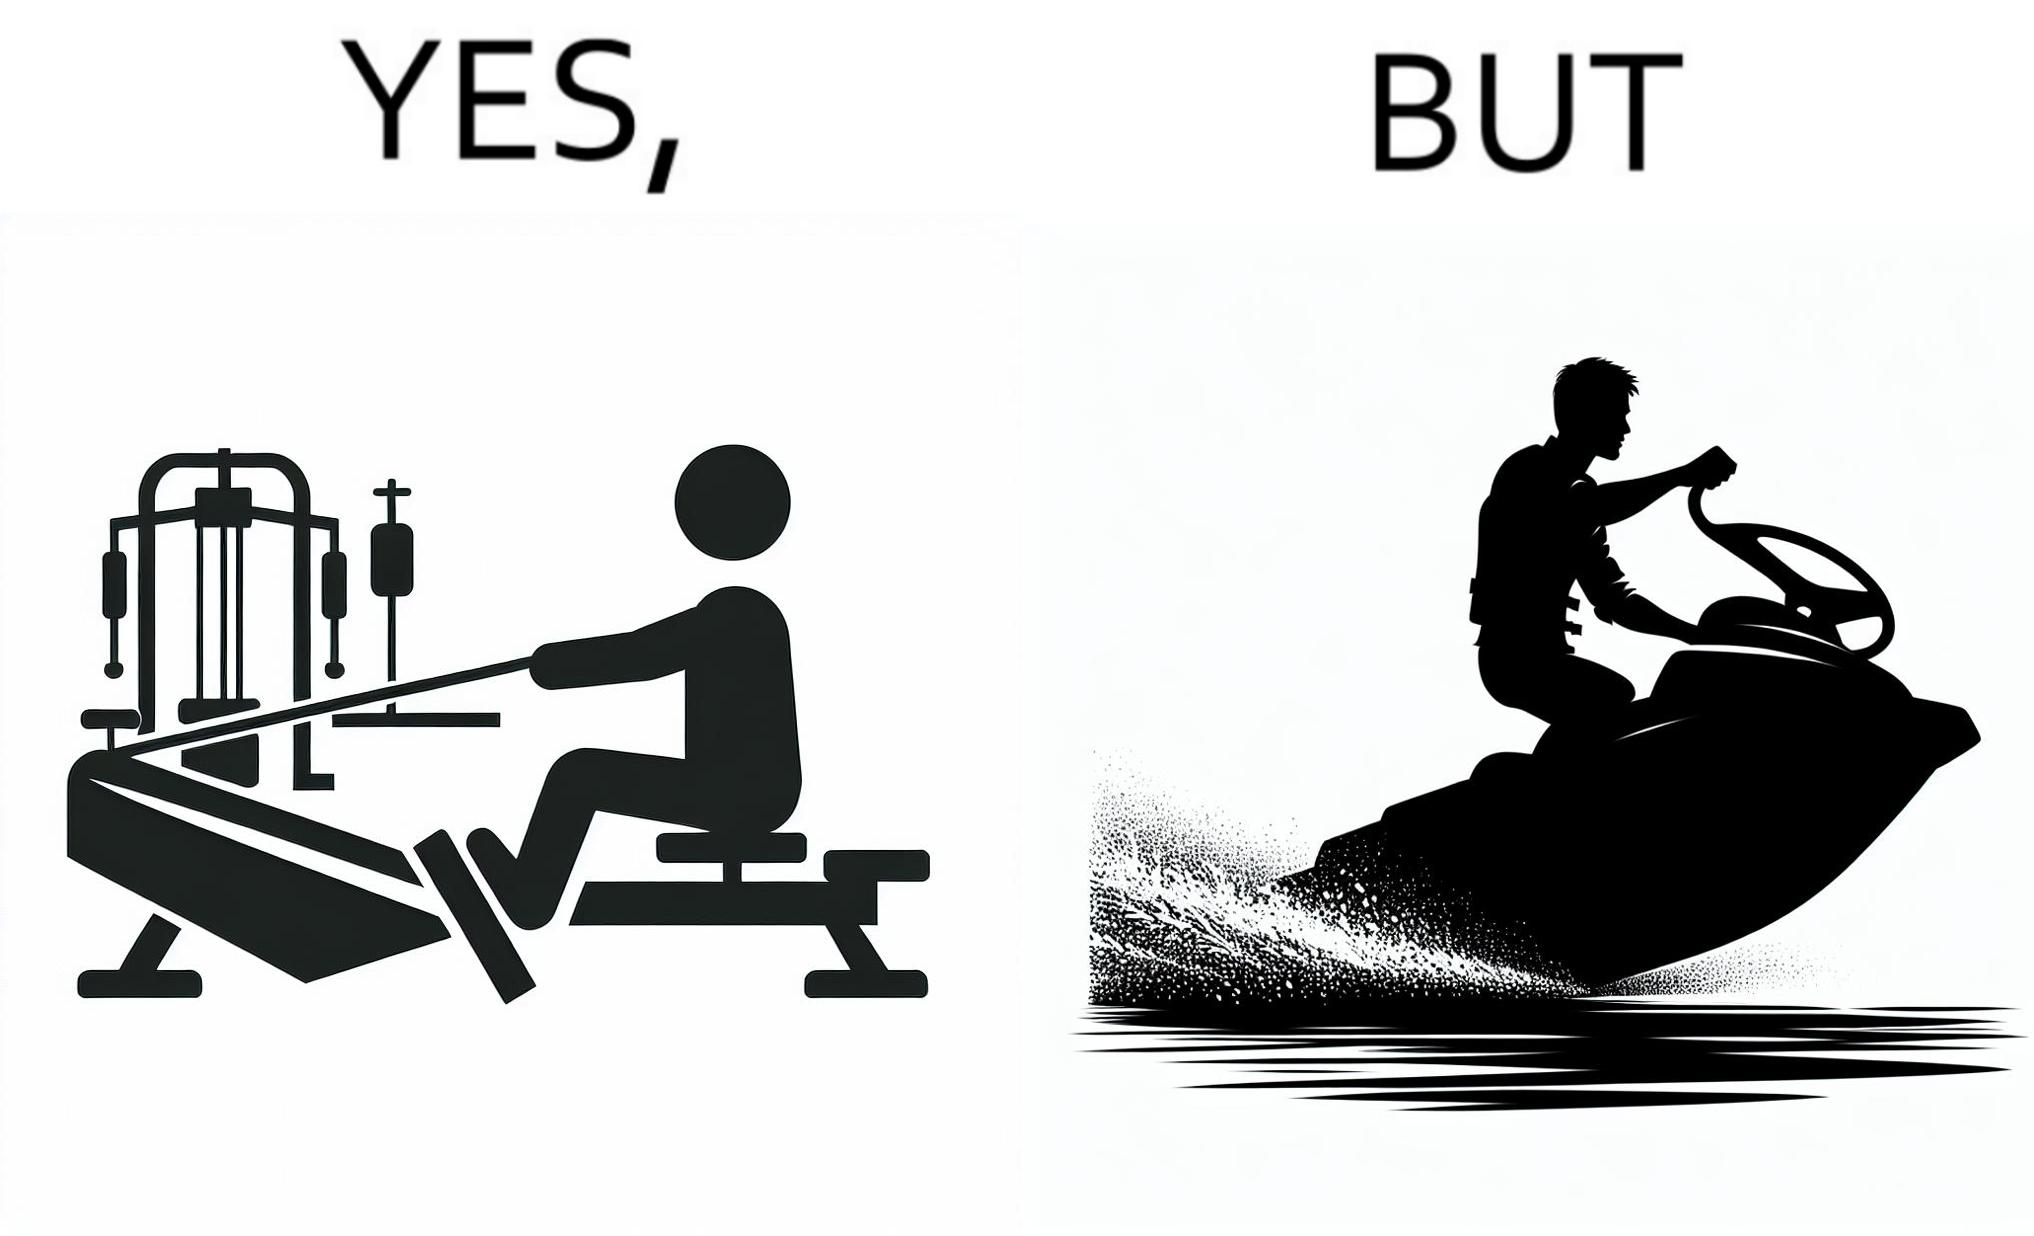Is this image satirical or non-satirical? Yes, this image is satirical. 